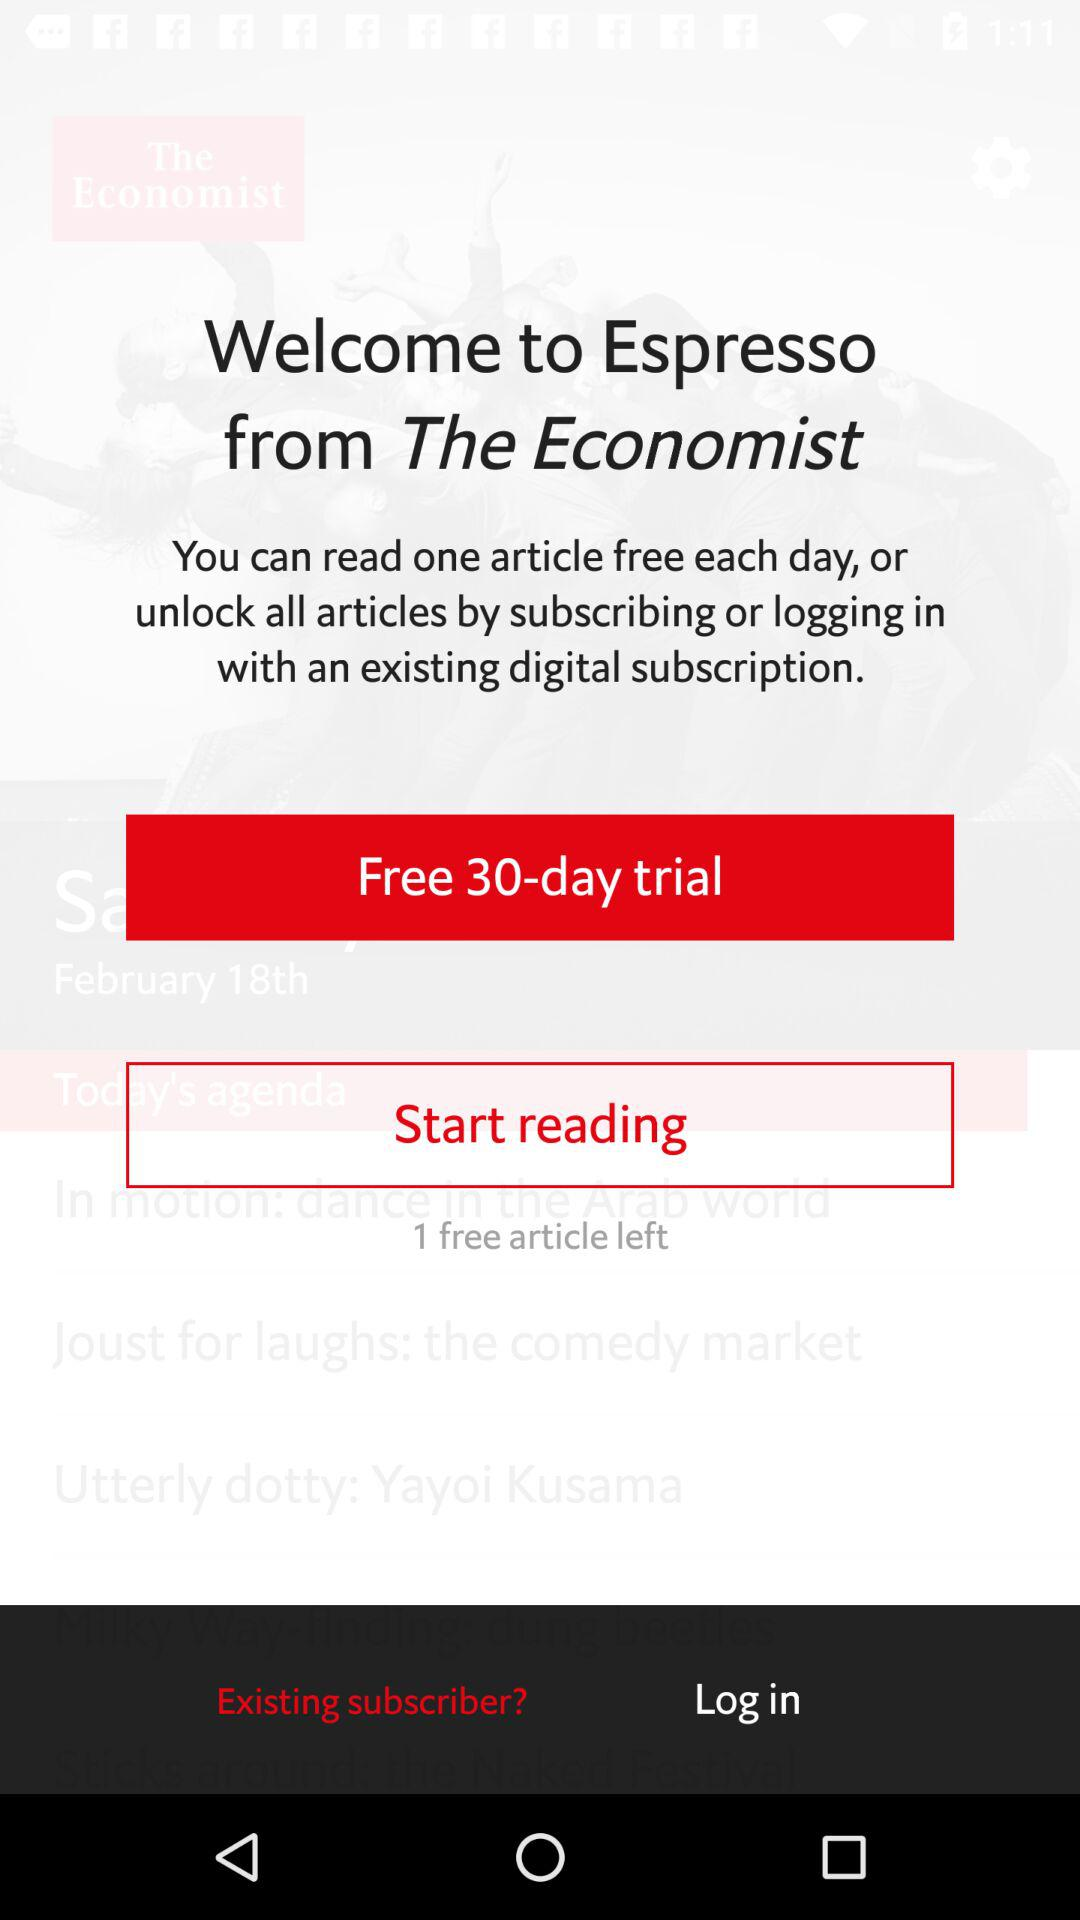How many articles are available to read for free?
Answer the question using a single word or phrase. 1 